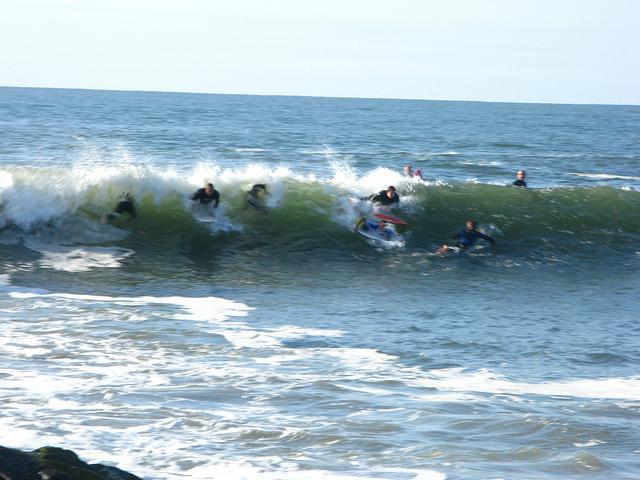How many red buses are there?
Give a very brief answer. 0. 